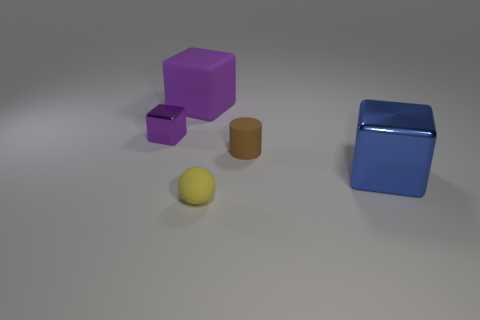How many other cubes are the same color as the small block?
Your answer should be very brief. 1. Are there any other small brown things of the same shape as the brown rubber object?
Your response must be concise. No. Are there fewer large purple matte cubes in front of the large blue shiny object than large red rubber things?
Give a very brief answer. No. Is the shape of the purple rubber object the same as the brown thing?
Keep it short and to the point. No. How big is the purple thing behind the purple metal object?
Give a very brief answer. Large. What is the size of the object that is the same material as the small purple cube?
Your response must be concise. Large. Is the number of red matte spheres less than the number of balls?
Keep it short and to the point. Yes. What material is the yellow ball that is the same size as the purple shiny thing?
Offer a terse response. Rubber. Is the number of yellow objects greater than the number of big gray shiny balls?
Keep it short and to the point. Yes. How many other objects are the same color as the sphere?
Your answer should be very brief. 0. 